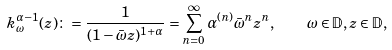Convert formula to latex. <formula><loc_0><loc_0><loc_500><loc_500>k _ { \omega } ^ { \alpha - 1 } ( z ) \colon = \frac { 1 } { ( 1 - \bar { \omega } z ) ^ { 1 + \alpha } } = \sum _ { n = 0 } ^ { \infty } \alpha ^ { ( n ) } \bar { \omega } ^ { n } z ^ { n } , \quad \omega \in \mathbb { D } , z \in \mathbb { D } ,</formula> 